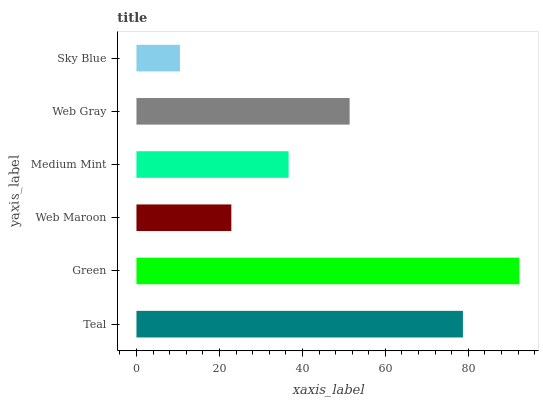Is Sky Blue the minimum?
Answer yes or no. Yes. Is Green the maximum?
Answer yes or no. Yes. Is Web Maroon the minimum?
Answer yes or no. No. Is Web Maroon the maximum?
Answer yes or no. No. Is Green greater than Web Maroon?
Answer yes or no. Yes. Is Web Maroon less than Green?
Answer yes or no. Yes. Is Web Maroon greater than Green?
Answer yes or no. No. Is Green less than Web Maroon?
Answer yes or no. No. Is Web Gray the high median?
Answer yes or no. Yes. Is Medium Mint the low median?
Answer yes or no. Yes. Is Medium Mint the high median?
Answer yes or no. No. Is Web Maroon the low median?
Answer yes or no. No. 